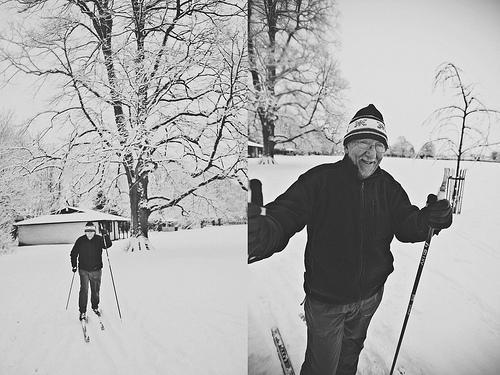How many buildings are in the background?
Give a very brief answer. 1. 